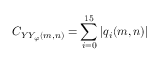Convert formula to latex. <formula><loc_0><loc_0><loc_500><loc_500>C _ { Y Y _ { \varphi } ( m , n ) } = \sum _ { i = 0 } ^ { 1 5 } \left | q _ { i } ( m , n ) \right |</formula> 